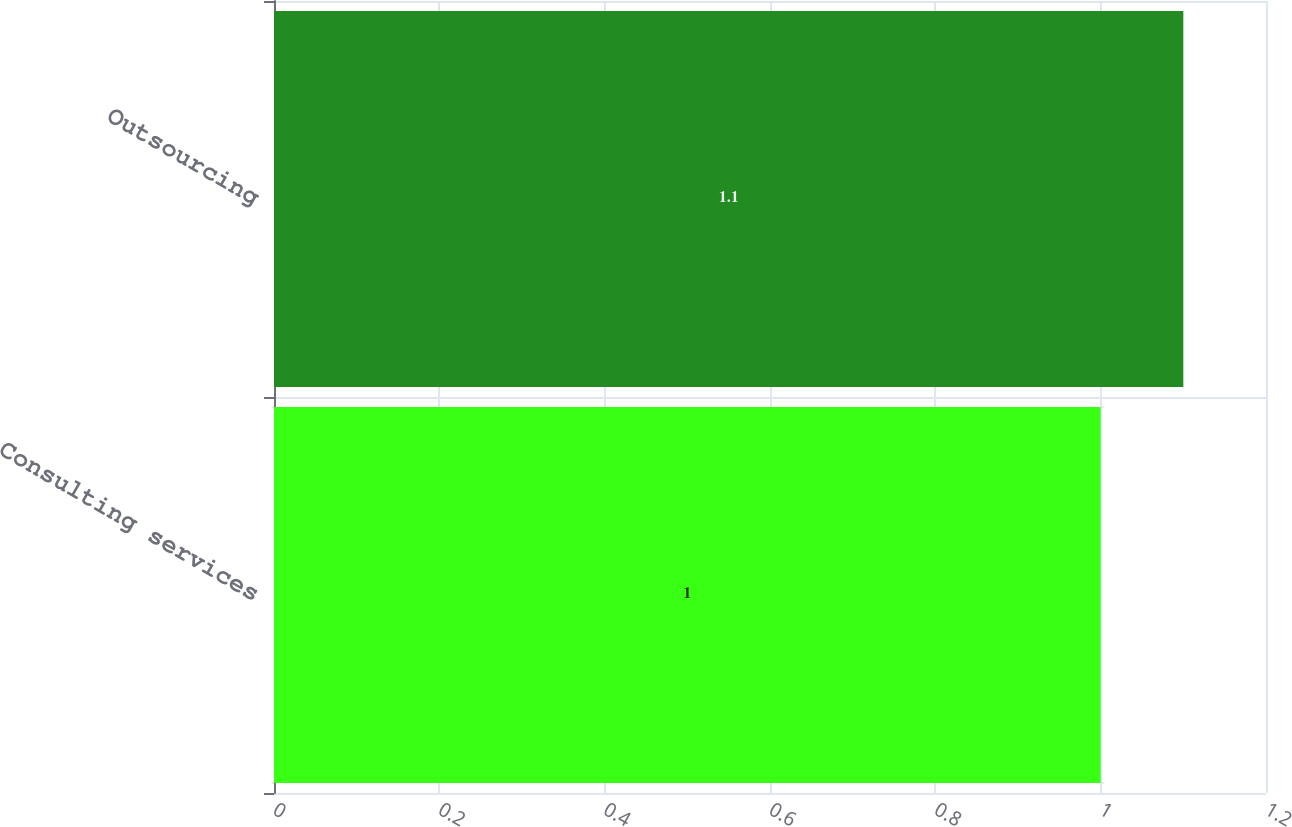Convert chart. <chart><loc_0><loc_0><loc_500><loc_500><bar_chart><fcel>Consulting services<fcel>Outsourcing<nl><fcel>1<fcel>1.1<nl></chart> 